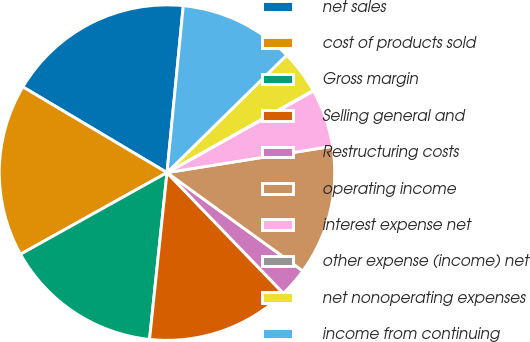Convert chart to OTSL. <chart><loc_0><loc_0><loc_500><loc_500><pie_chart><fcel>net sales<fcel>cost of products sold<fcel>Gross margin<fcel>Selling general and<fcel>Restructuring costs<fcel>operating income<fcel>interest expense net<fcel>other expense (income) net<fcel>net nonoperating expenses<fcel>income from continuing<nl><fcel>18.01%<fcel>16.63%<fcel>15.25%<fcel>13.87%<fcel>2.82%<fcel>12.49%<fcel>5.58%<fcel>0.06%<fcel>4.2%<fcel>11.1%<nl></chart> 